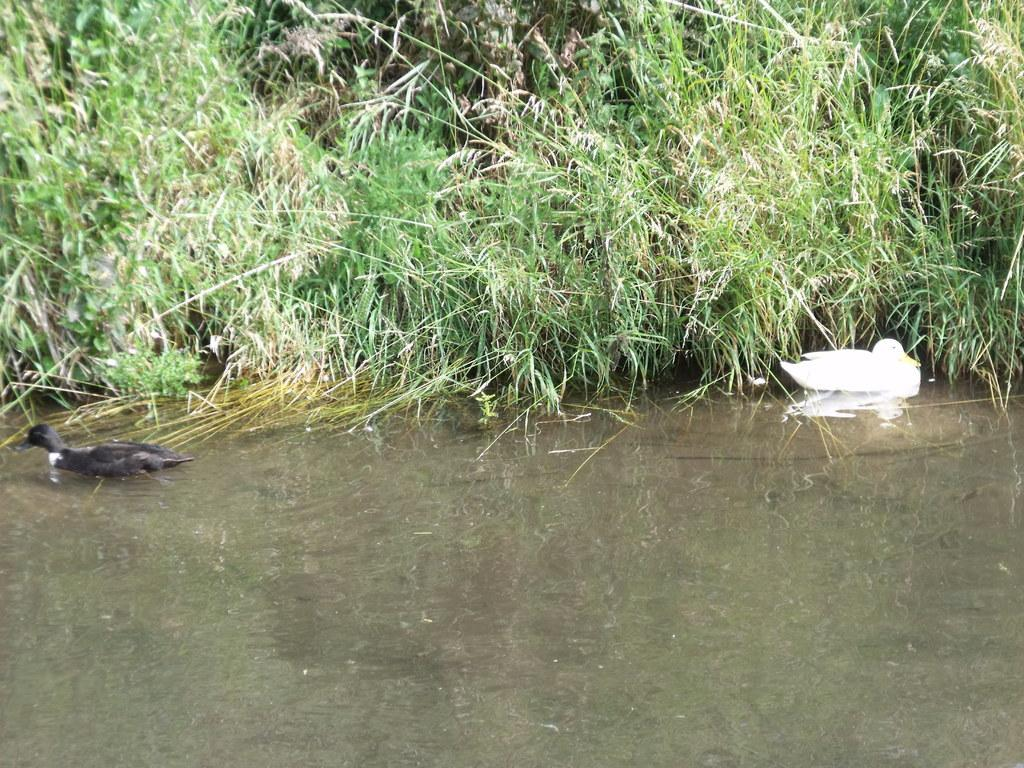What type of living organisms can be seen in the image? Plants and ducks can be seen in the image. What type of vegetation is visible in the image? There is grass visible in the image. Where are the ducks located in the image? The ducks are in the water in the image. Can you tell me how many requests the squirrel made in the image? There is no squirrel present in the image, so it is not possible to determine how many requests it made. 